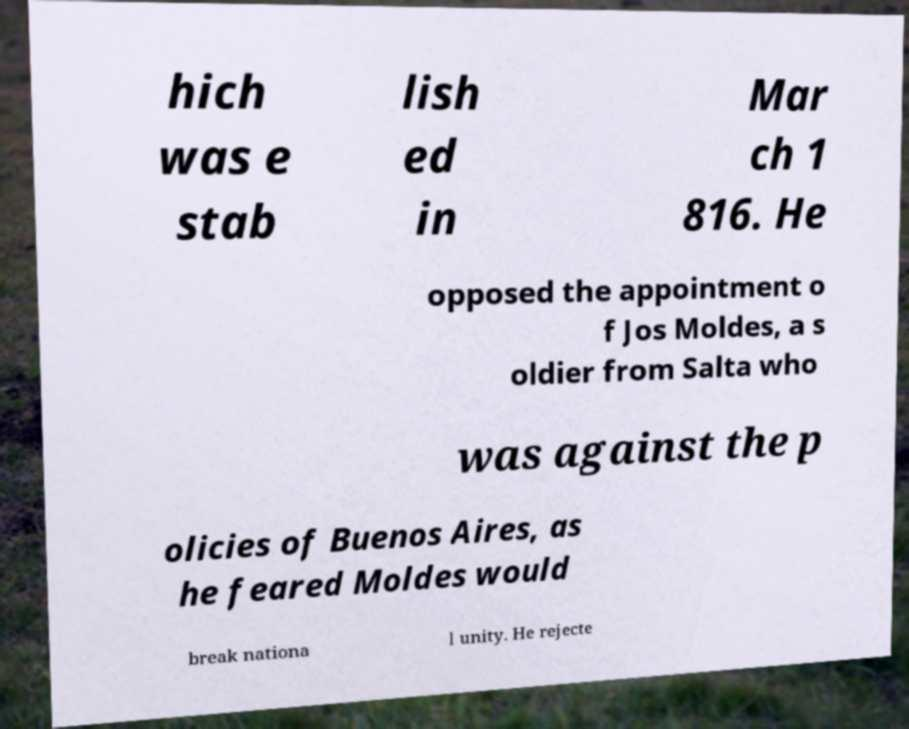Can you read and provide the text displayed in the image?This photo seems to have some interesting text. Can you extract and type it out for me? hich was e stab lish ed in Mar ch 1 816. He opposed the appointment o f Jos Moldes, a s oldier from Salta who was against the p olicies of Buenos Aires, as he feared Moldes would break nationa l unity. He rejecte 